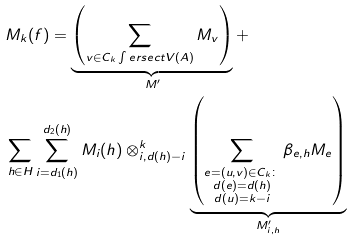Convert formula to latex. <formula><loc_0><loc_0><loc_500><loc_500>& M _ { k } ( f ) = \underbrace { \left ( \sum _ { v \in C _ { k } \int e r s e c t V ( A ) } M _ { v } \right ) } _ { M ^ { \prime } } + \\ & \sum _ { h \in H } \sum _ { i = d _ { 1 } ( h ) } ^ { d _ { 2 } ( h ) } M _ { i } ( h ) \otimes _ { i , d ( h ) - i } ^ { k } \underbrace { \left ( \sum _ { \substack { e = ( u , v ) \in C _ { k } \colon \\ d ( e ) = d ( h ) \\ d ( u ) = k - i } } \beta _ { e , h } M _ { e } \right ) } _ { M ^ { \prime } _ { i , h } }</formula> 